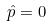Convert formula to latex. <formula><loc_0><loc_0><loc_500><loc_500>\hat { p } = 0</formula> 